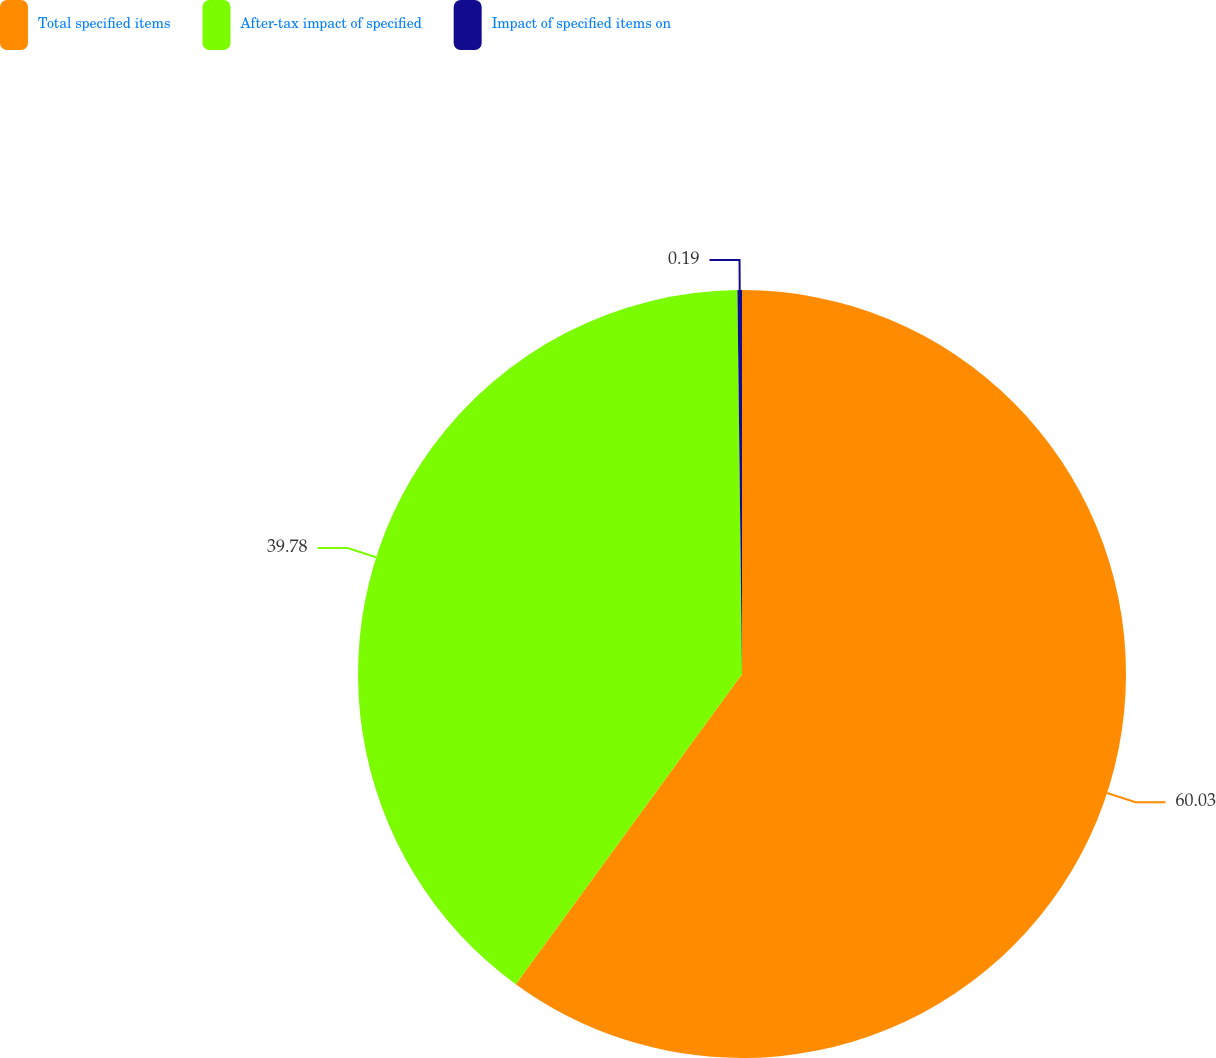<chart> <loc_0><loc_0><loc_500><loc_500><pie_chart><fcel>Total specified items<fcel>After-tax impact of specified<fcel>Impact of specified items on<nl><fcel>60.03%<fcel>39.78%<fcel>0.19%<nl></chart> 